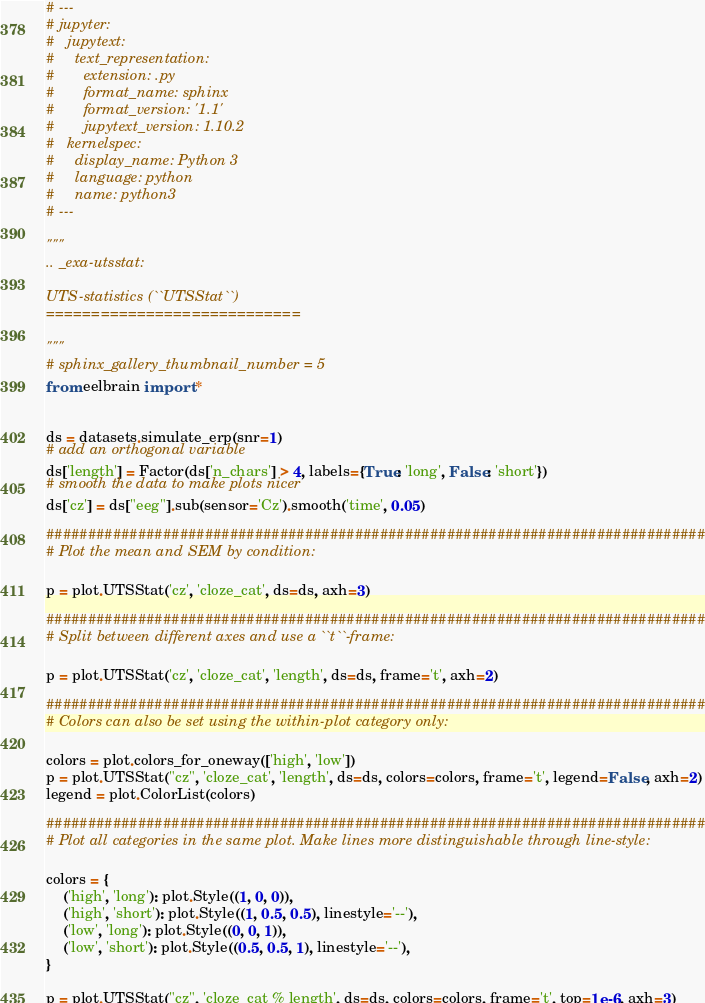Convert code to text. <code><loc_0><loc_0><loc_500><loc_500><_Python_># ---
# jupyter:
#   jupytext:
#     text_representation:
#       extension: .py
#       format_name: sphinx
#       format_version: '1.1'
#       jupytext_version: 1.10.2
#   kernelspec:
#     display_name: Python 3
#     language: python
#     name: python3
# ---

"""
.. _exa-utsstat:

UTS-statistics (``UTSStat``)
============================

"""
# sphinx_gallery_thumbnail_number = 5
from eelbrain import *


ds = datasets.simulate_erp(snr=1)
# add an orthogonal variable
ds['length'] = Factor(ds['n_chars'] > 4, labels={True: 'long', False: 'short'})
# smooth the data to make plots nicer
ds['cz'] = ds["eeg"].sub(sensor='Cz').smooth('time', 0.05)

###############################################################################
# Plot the mean and SEM by condition:

p = plot.UTSStat('cz', 'cloze_cat', ds=ds, axh=3)

###############################################################################
# Split between different axes and use a ``t``-frame:

p = plot.UTSStat('cz', 'cloze_cat', 'length', ds=ds, frame='t', axh=2)

###############################################################################
# Colors can also be set using the within-plot category only:

colors = plot.colors_for_oneway(['high', 'low'])
p = plot.UTSStat("cz", 'cloze_cat', 'length', ds=ds, colors=colors, frame='t', legend=False, axh=2)
legend = plot.ColorList(colors)

###############################################################################
# Plot all categories in the same plot. Make lines more distinguishable through line-style:

colors = {
    ('high', 'long'): plot.Style((1, 0, 0)),
    ('high', 'short'): plot.Style((1, 0.5, 0.5), linestyle='--'),
    ('low', 'long'): plot.Style((0, 0, 1)),
    ('low', 'short'): plot.Style((0.5, 0.5, 1), linestyle='--'),
}

p = plot.UTSStat("cz", 'cloze_cat % length', ds=ds, colors=colors, frame='t', top=1e-6, axh=3)
</code> 